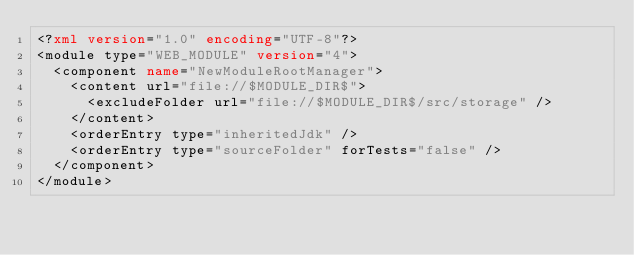Convert code to text. <code><loc_0><loc_0><loc_500><loc_500><_XML_><?xml version="1.0" encoding="UTF-8"?>
<module type="WEB_MODULE" version="4">
  <component name="NewModuleRootManager">
    <content url="file://$MODULE_DIR$">
      <excludeFolder url="file://$MODULE_DIR$/src/storage" />
    </content>
    <orderEntry type="inheritedJdk" />
    <orderEntry type="sourceFolder" forTests="false" />
  </component>
</module></code> 